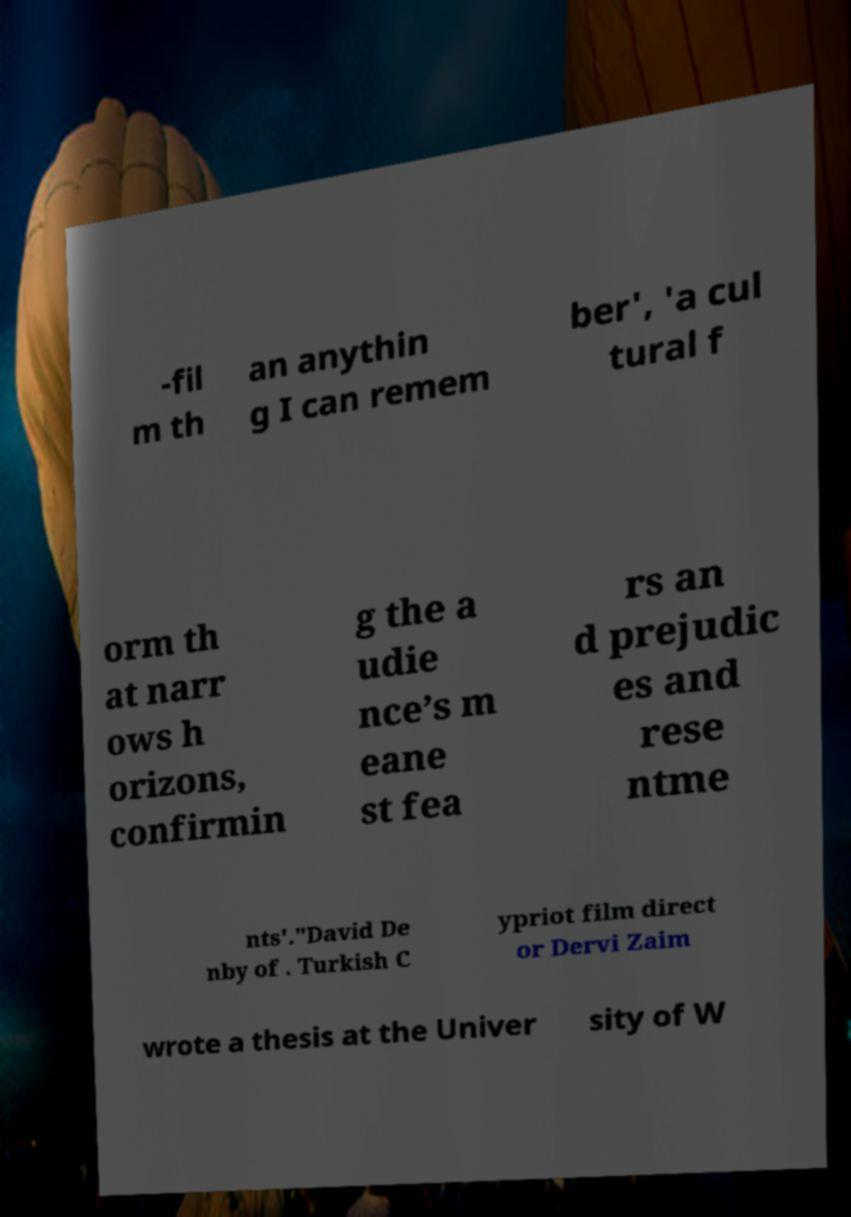Please read and relay the text visible in this image. What does it say? -fil m th an anythin g I can remem ber', 'a cul tural f orm th at narr ows h orizons, confirmin g the a udie nce’s m eane st fea rs an d prejudic es and rese ntme nts'."David De nby of . Turkish C ypriot film direct or Dervi Zaim wrote a thesis at the Univer sity of W 